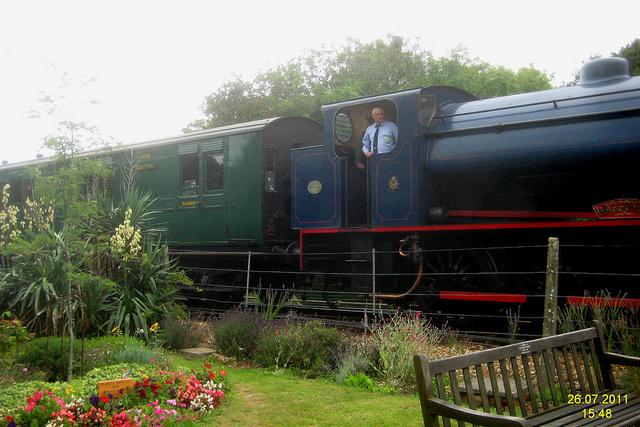What is the man wearing? Please explain your reasoning. tie. A man is dressed in a dress shirt with a necktie and standing on a blue train by the opening of it. 